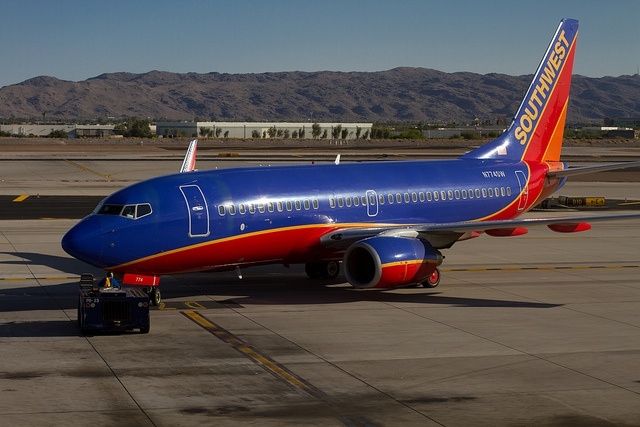Describe the objects in this image and their specific colors. I can see airplane in gray, navy, black, darkblue, and blue tones, truck in gray, black, maroon, and navy tones, and people in gray, black, navy, maroon, and darkgreen tones in this image. 